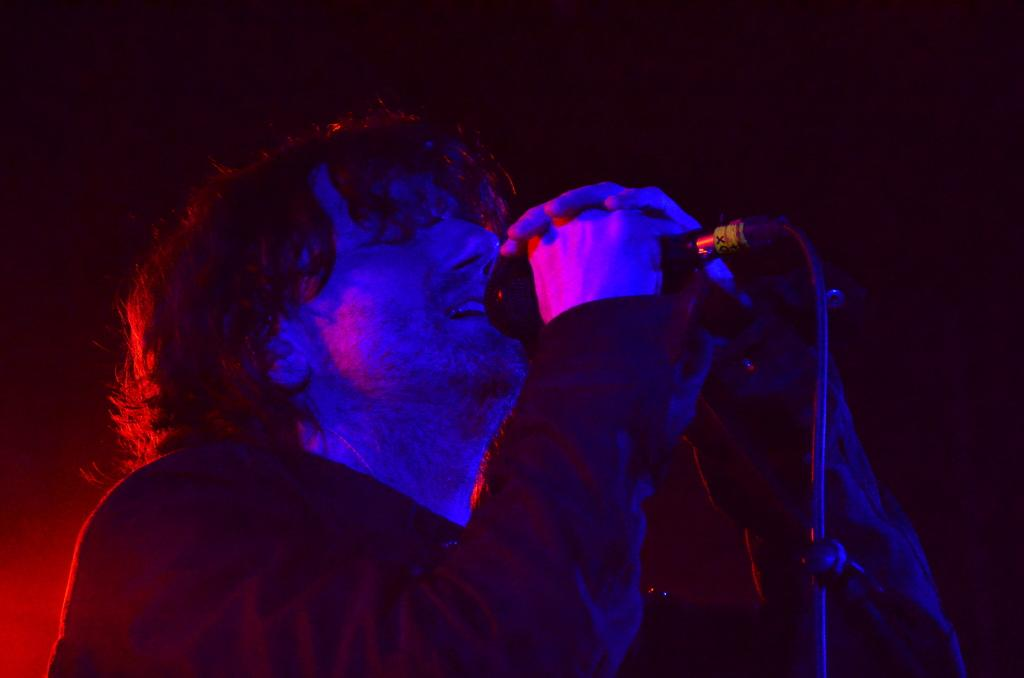Who is the main subject in the image? There is a man in the image. What is the man holding in his hands? The man is holding a mic with his hands. Can you describe the background of the image? The background of the image is dark. What type of wine is the man drinking in the image? There is no wine present in the image; the man is holding a mic. Is there a bag visible in the image? No, there is no bag visible in the image. 